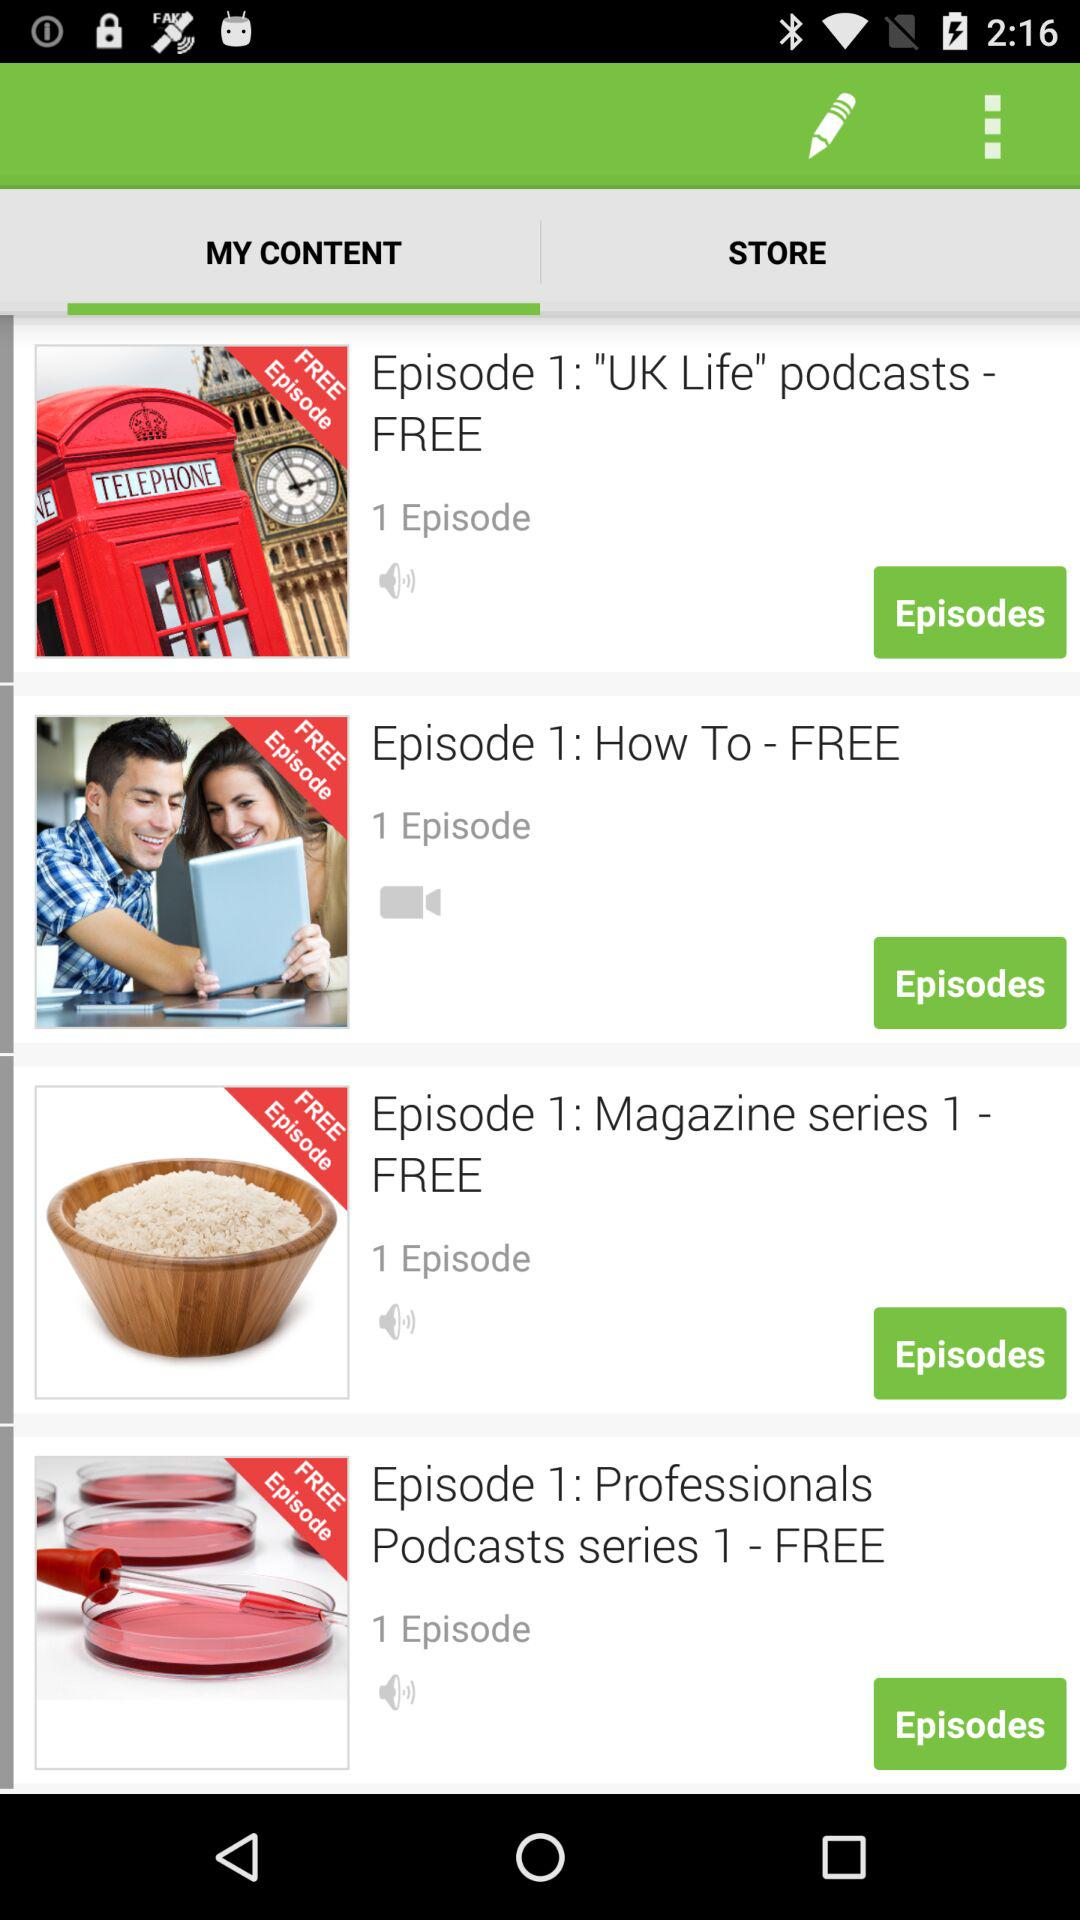How many of the free episodes are from the Professionals Podcasts series?
Answer the question using a single word or phrase. 1 